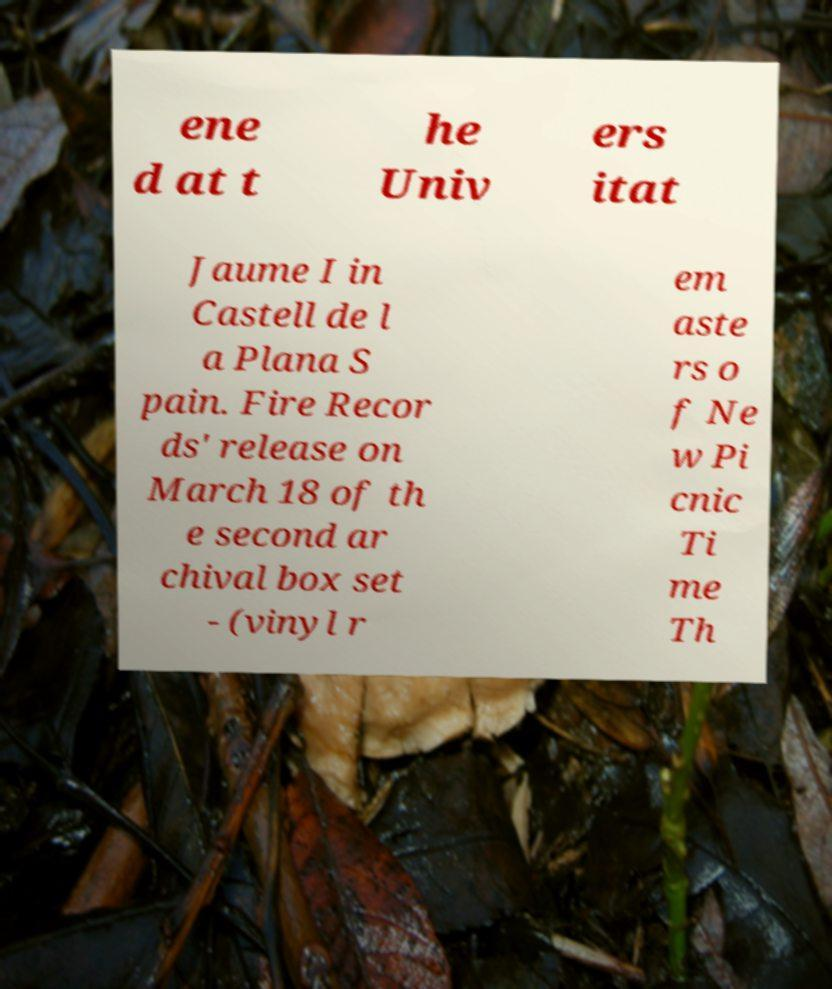Could you extract and type out the text from this image? ene d at t he Univ ers itat Jaume I in Castell de l a Plana S pain. Fire Recor ds' release on March 18 of th e second ar chival box set - (vinyl r em aste rs o f Ne w Pi cnic Ti me Th 